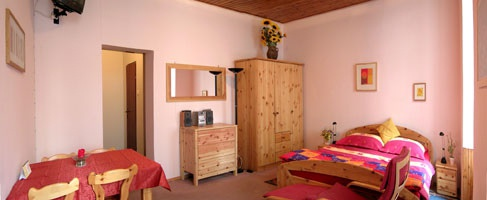Describe the objects in this image and their specific colors. I can see bed in tan, violet, brown, and salmon tones, dining table in tan and brown tones, chair in tan, salmon, and red tones, chair in tan, maroon, brown, and black tones, and potted plant in tan, maroon, olive, black, and gray tones in this image. 